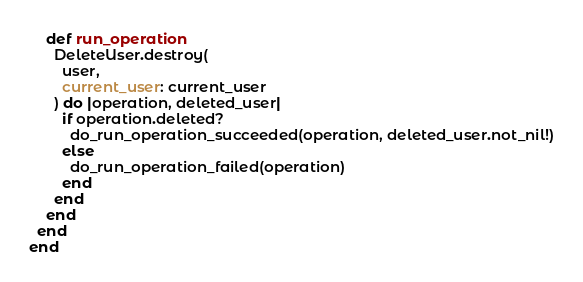<code> <loc_0><loc_0><loc_500><loc_500><_Crystal_>
    def run_operation
      DeleteUser.destroy(
        user,
        current_user: current_user
      ) do |operation, deleted_user|
        if operation.deleted?
          do_run_operation_succeeded(operation, deleted_user.not_nil!)
        else
          do_run_operation_failed(operation)
        end
      end
    end
  end
end
</code> 